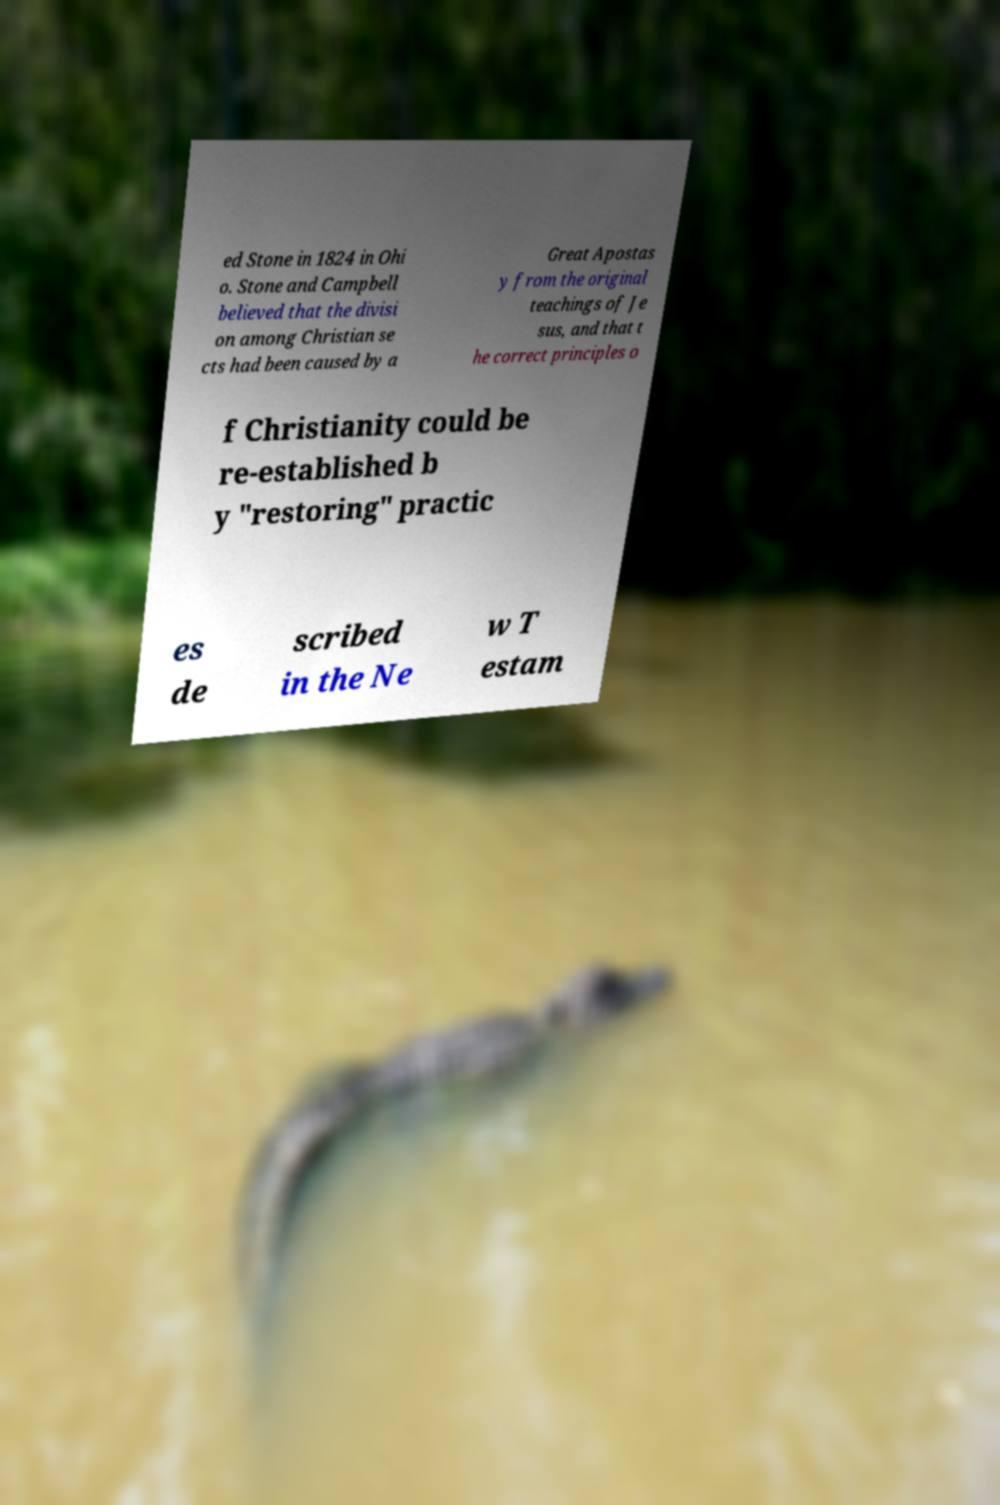What messages or text are displayed in this image? I need them in a readable, typed format. ed Stone in 1824 in Ohi o. Stone and Campbell believed that the divisi on among Christian se cts had been caused by a Great Apostas y from the original teachings of Je sus, and that t he correct principles o f Christianity could be re-established b y "restoring" practic es de scribed in the Ne w T estam 